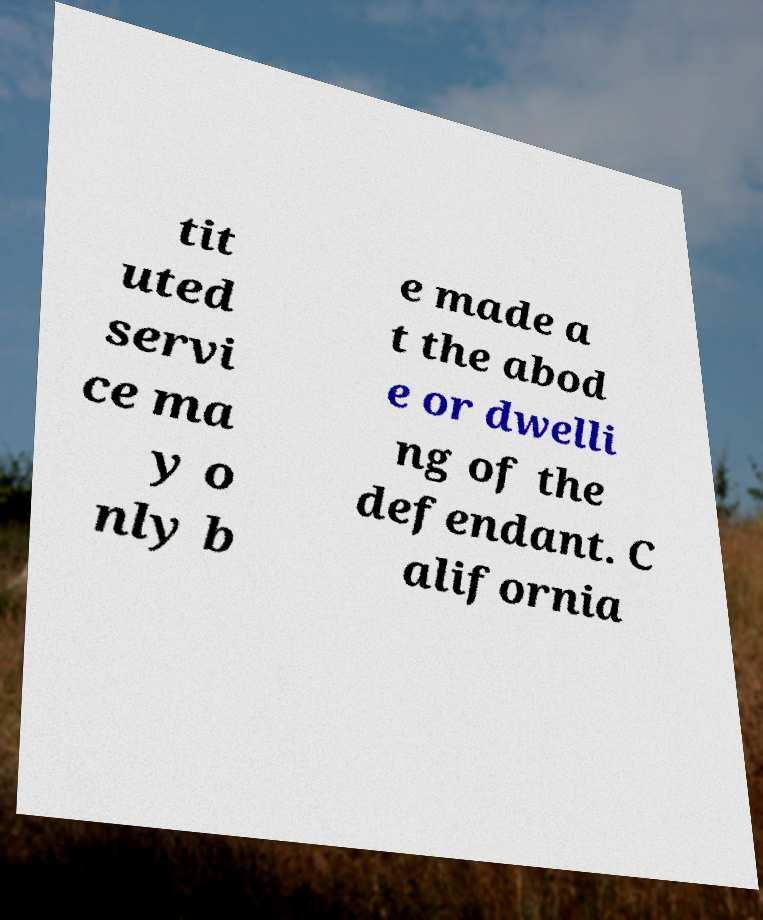Please identify and transcribe the text found in this image. tit uted servi ce ma y o nly b e made a t the abod e or dwelli ng of the defendant. C alifornia 